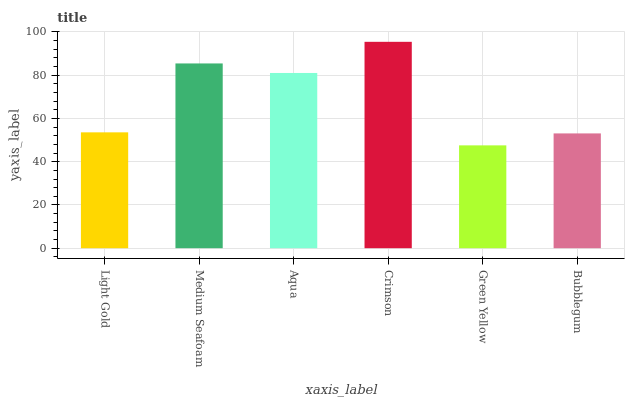Is Green Yellow the minimum?
Answer yes or no. Yes. Is Crimson the maximum?
Answer yes or no. Yes. Is Medium Seafoam the minimum?
Answer yes or no. No. Is Medium Seafoam the maximum?
Answer yes or no. No. Is Medium Seafoam greater than Light Gold?
Answer yes or no. Yes. Is Light Gold less than Medium Seafoam?
Answer yes or no. Yes. Is Light Gold greater than Medium Seafoam?
Answer yes or no. No. Is Medium Seafoam less than Light Gold?
Answer yes or no. No. Is Aqua the high median?
Answer yes or no. Yes. Is Light Gold the low median?
Answer yes or no. Yes. Is Crimson the high median?
Answer yes or no. No. Is Bubblegum the low median?
Answer yes or no. No. 